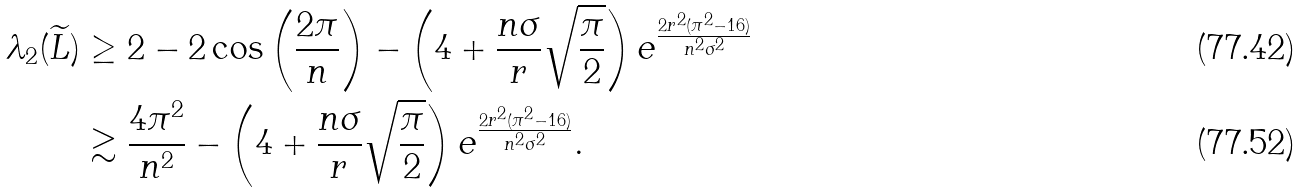<formula> <loc_0><loc_0><loc_500><loc_500>\lambda _ { 2 } ( \widetilde { L } ) & \geq 2 - 2 \cos \left ( \frac { 2 \pi } { n } \right ) - \left ( 4 + \frac { n \sigma } { r } \sqrt { \frac { \pi } { 2 } } \right ) e ^ { \frac { 2 r ^ { 2 } ( \pi ^ { 2 } - 1 6 ) } { n ^ { 2 } \sigma ^ { 2 } } } \\ & \gtrsim \frac { 4 \pi ^ { 2 } } { n ^ { 2 } } - \left ( 4 + \frac { n \sigma } { r } \sqrt { \frac { \pi } { 2 } } \right ) e ^ { \frac { 2 r ^ { 2 } ( \pi ^ { 2 } - 1 6 ) } { n ^ { 2 } \sigma ^ { 2 } } } .</formula> 